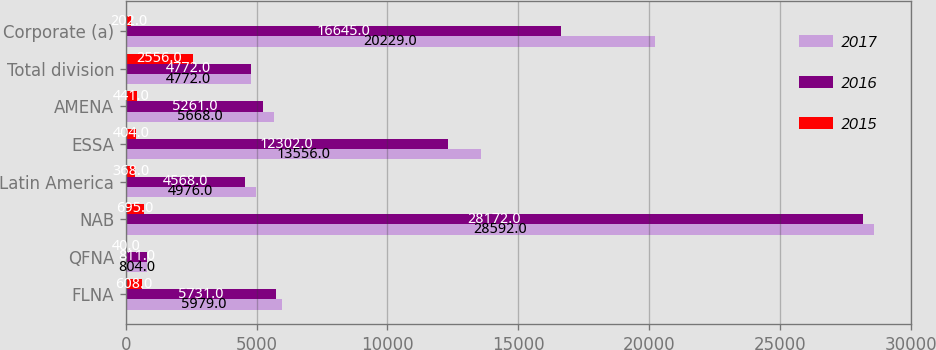Convert chart. <chart><loc_0><loc_0><loc_500><loc_500><stacked_bar_chart><ecel><fcel>FLNA<fcel>QFNA<fcel>NAB<fcel>Latin America<fcel>ESSA<fcel>AMENA<fcel>Total division<fcel>Corporate (a)<nl><fcel>2017<fcel>5979<fcel>804<fcel>28592<fcel>4976<fcel>13556<fcel>5668<fcel>4772<fcel>20229<nl><fcel>2016<fcel>5731<fcel>811<fcel>28172<fcel>4568<fcel>12302<fcel>5261<fcel>4772<fcel>16645<nl><fcel>2015<fcel>608<fcel>40<fcel>695<fcel>368<fcel>404<fcel>441<fcel>2556<fcel>202<nl></chart> 